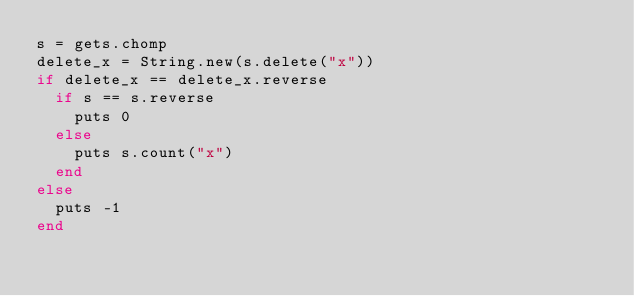<code> <loc_0><loc_0><loc_500><loc_500><_Ruby_>s = gets.chomp
delete_x = String.new(s.delete("x"))
if delete_x == delete_x.reverse
  if s == s.reverse
    puts 0
  else
    puts s.count("x")
  end
else
  puts -1
end</code> 